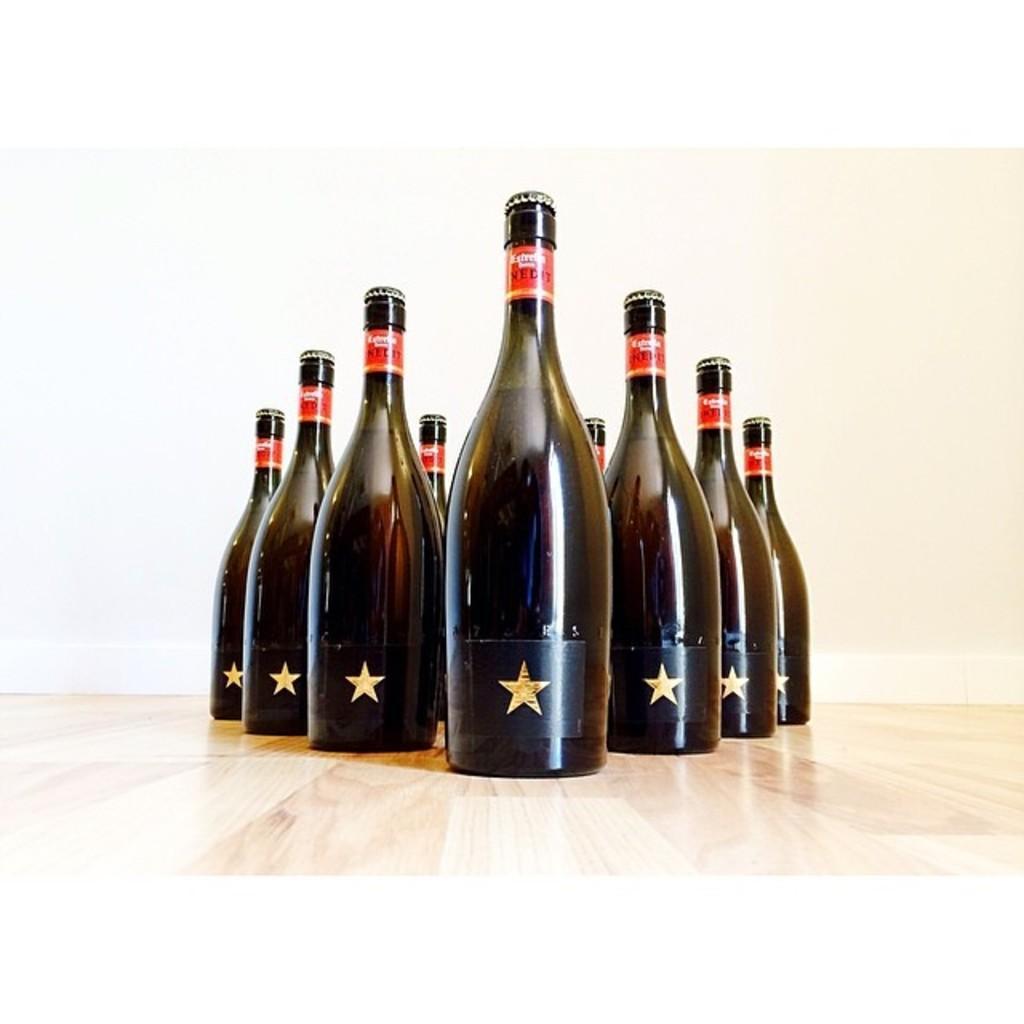Describe this image in one or two sentences. This picture is mainly highlighted with bottles which are arranged in a design format on the table. 